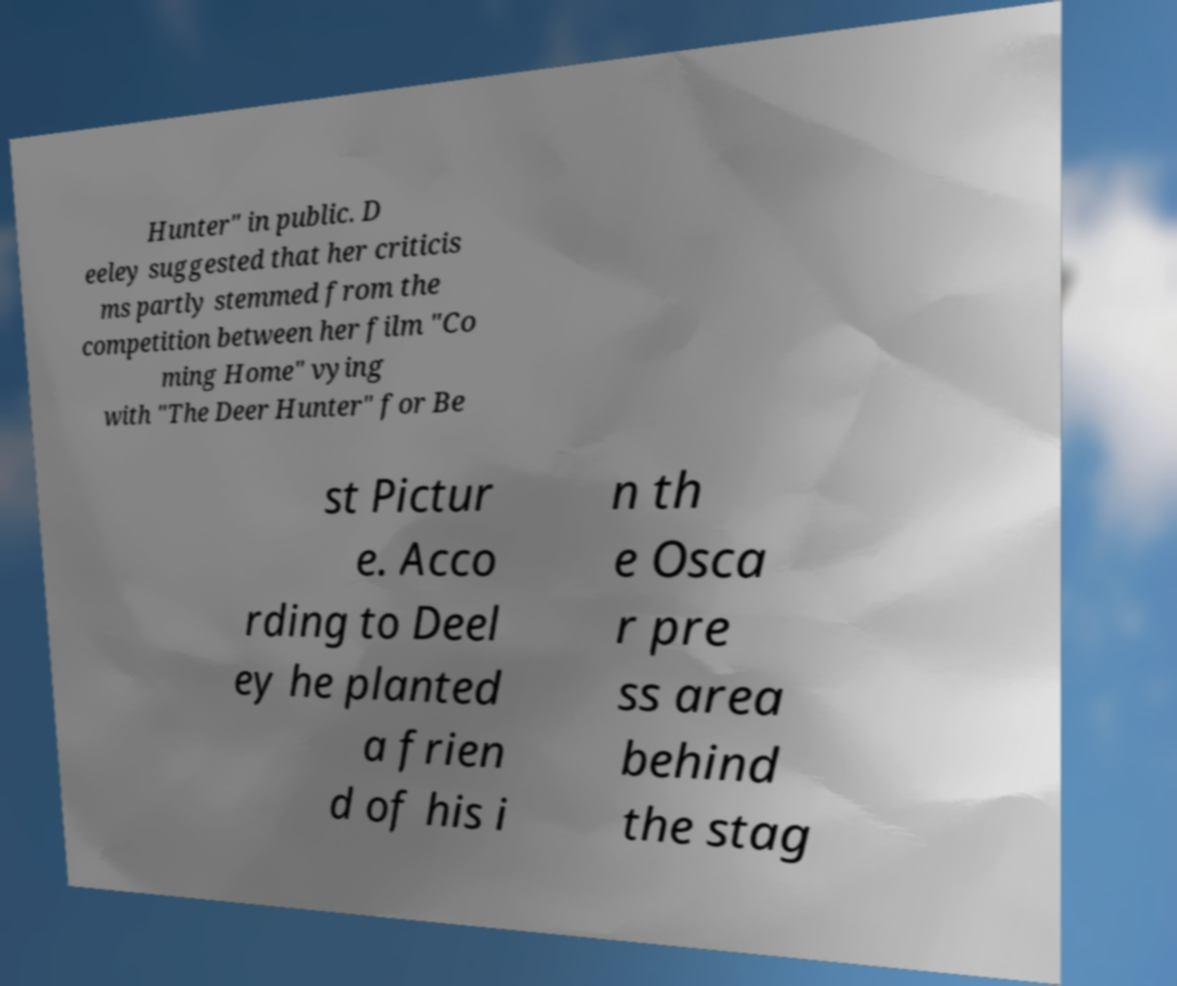Can you read and provide the text displayed in the image?This photo seems to have some interesting text. Can you extract and type it out for me? Hunter" in public. D eeley suggested that her criticis ms partly stemmed from the competition between her film "Co ming Home" vying with "The Deer Hunter" for Be st Pictur e. Acco rding to Deel ey he planted a frien d of his i n th e Osca r pre ss area behind the stag 